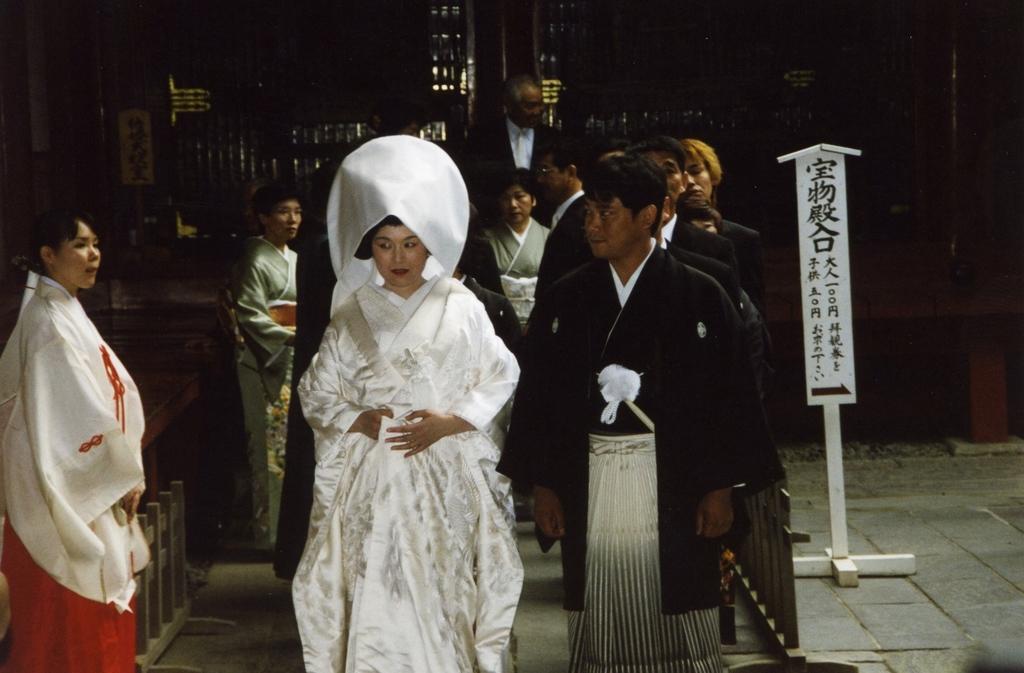Please provide a concise description of this image. There is a lady wearing a white dress. Also there are many people. On the right side there is a pole with a board. In the background it is dark. On the left side there is something on the ground. 